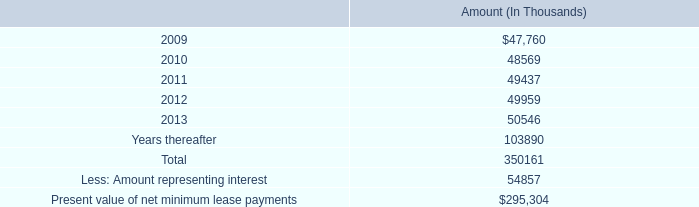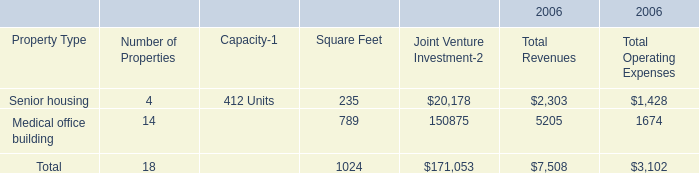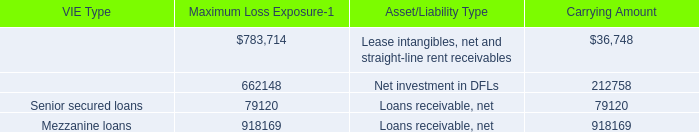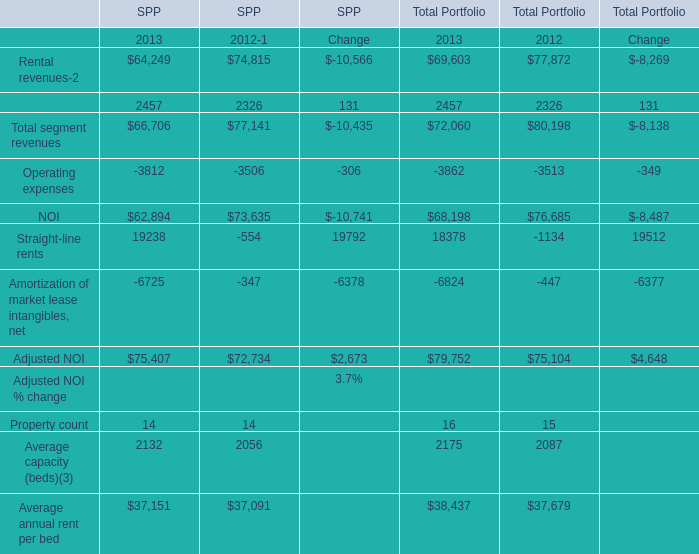what percent of lease payments are due after 2013? 
Computations: (103890 / 350161)
Answer: 0.29669. 